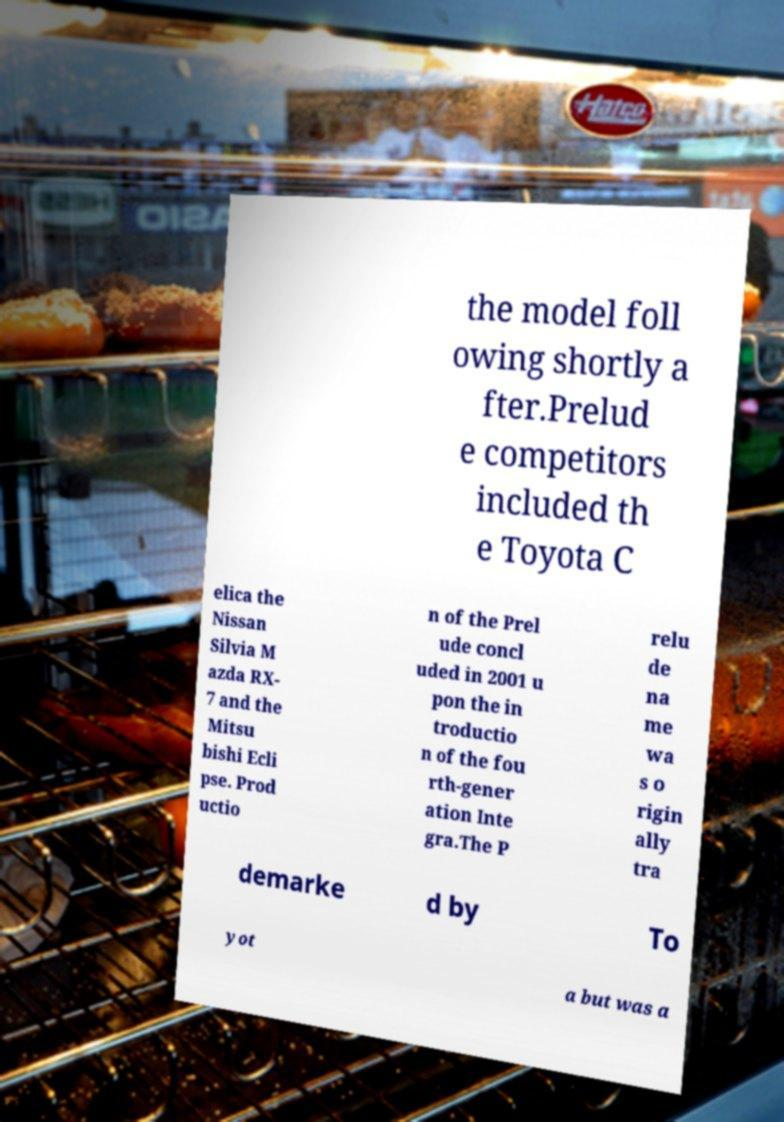For documentation purposes, I need the text within this image transcribed. Could you provide that? the model foll owing shortly a fter.Prelud e competitors included th e Toyota C elica the Nissan Silvia M azda RX- 7 and the Mitsu bishi Ecli pse. Prod uctio n of the Prel ude concl uded in 2001 u pon the in troductio n of the fou rth-gener ation Inte gra.The P relu de na me wa s o rigin ally tra demarke d by To yot a but was a 